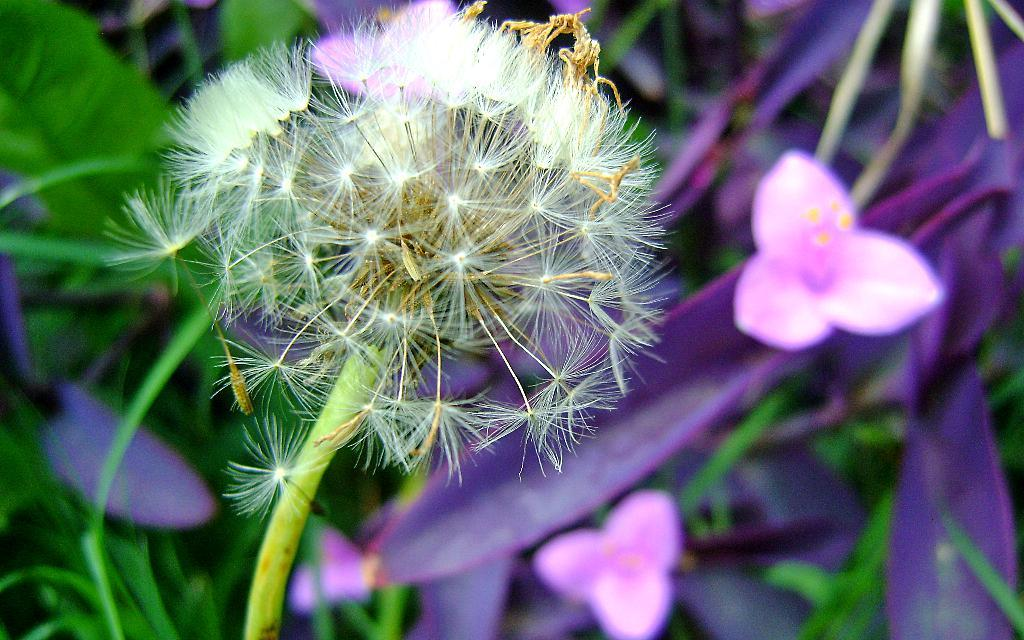What type of flower is in the image? There is a dandelion flower in the image. Where is the flower located in the image? The flower is on a plant. What color is the background of the flower? The background of the flower is blue. What type of reaction does the flower have when exposed to sunlight in the image? The image does not show any reaction of the flower to sunlight, as it only depicts the flower on a plant with a blue background. 